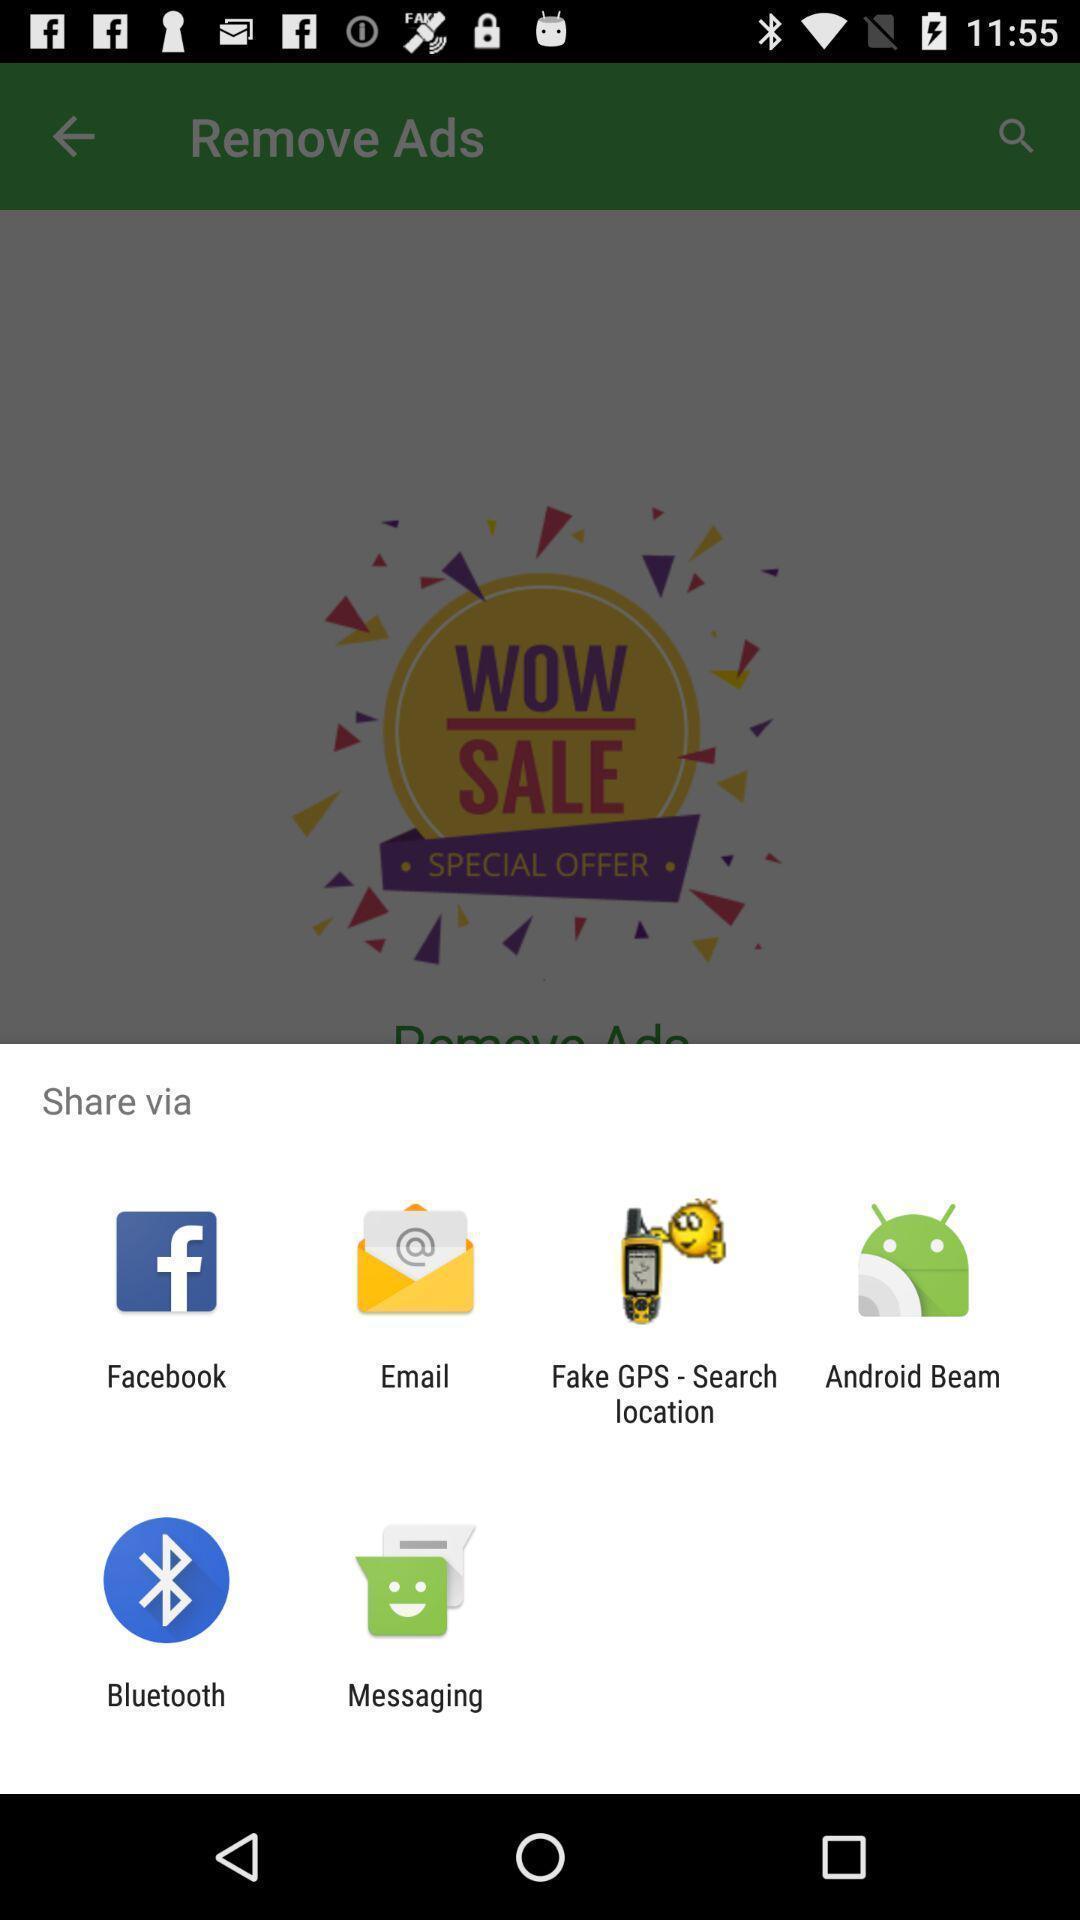Give me a summary of this screen capture. Push up page showing app preference to share. 